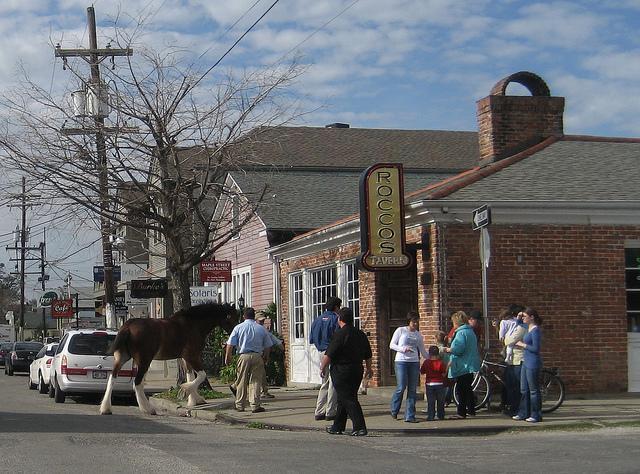How many people are there?
Give a very brief answer. 5. How many ski boards are in the picture?
Give a very brief answer. 0. 